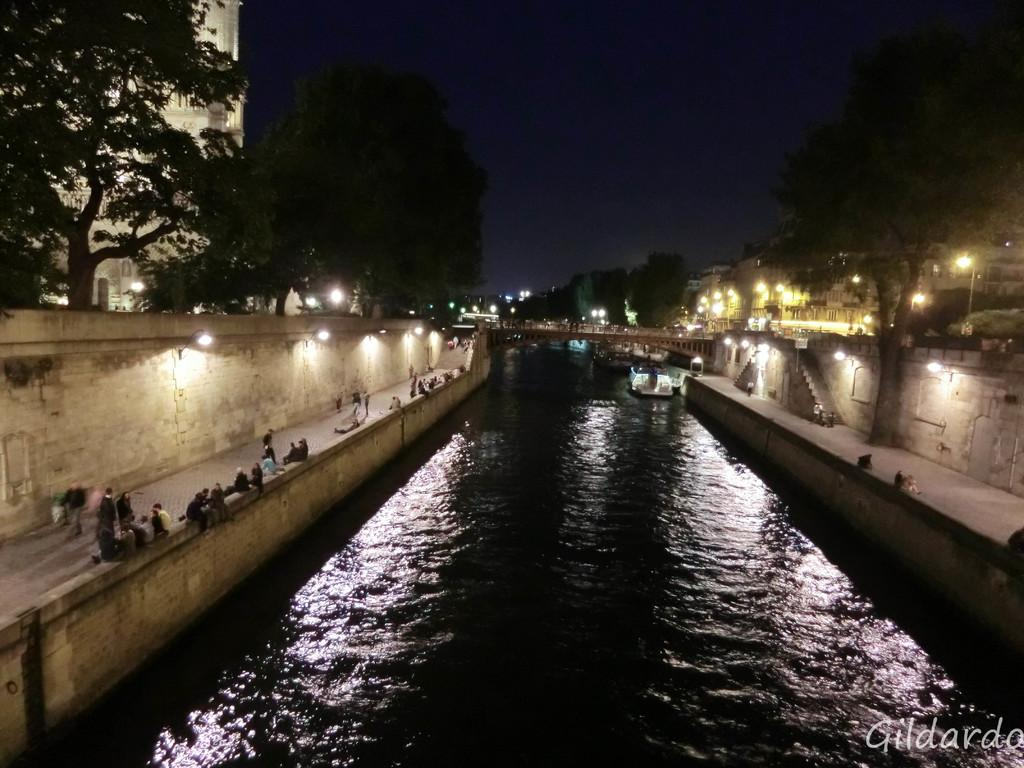What structure can be seen in the image that connects two areas? There is a bridge in the image that connects two areas. What is the bridge positioned above? The bridge is above water. What type of vegetation is present in the image? There are trees in the image. What are the poles in the image used for? The poles in the image are likely used for supporting the bridge or other structures. What can be seen illuminating the area in the image? There are lights in the image. Who or what is present in the image besides the bridge and its surroundings? There are people and dogs in the image. What is the staircase used for in the image? The staircase in the image is likely used for accessing the bridge or other areas. What is visible in the background of the image? The sky is visible in the background of the image. What type of lettuce is being used as a decoration on the bridge in the image? There is no lettuce present in the image, and it is not being used as a decoration on the bridge. 